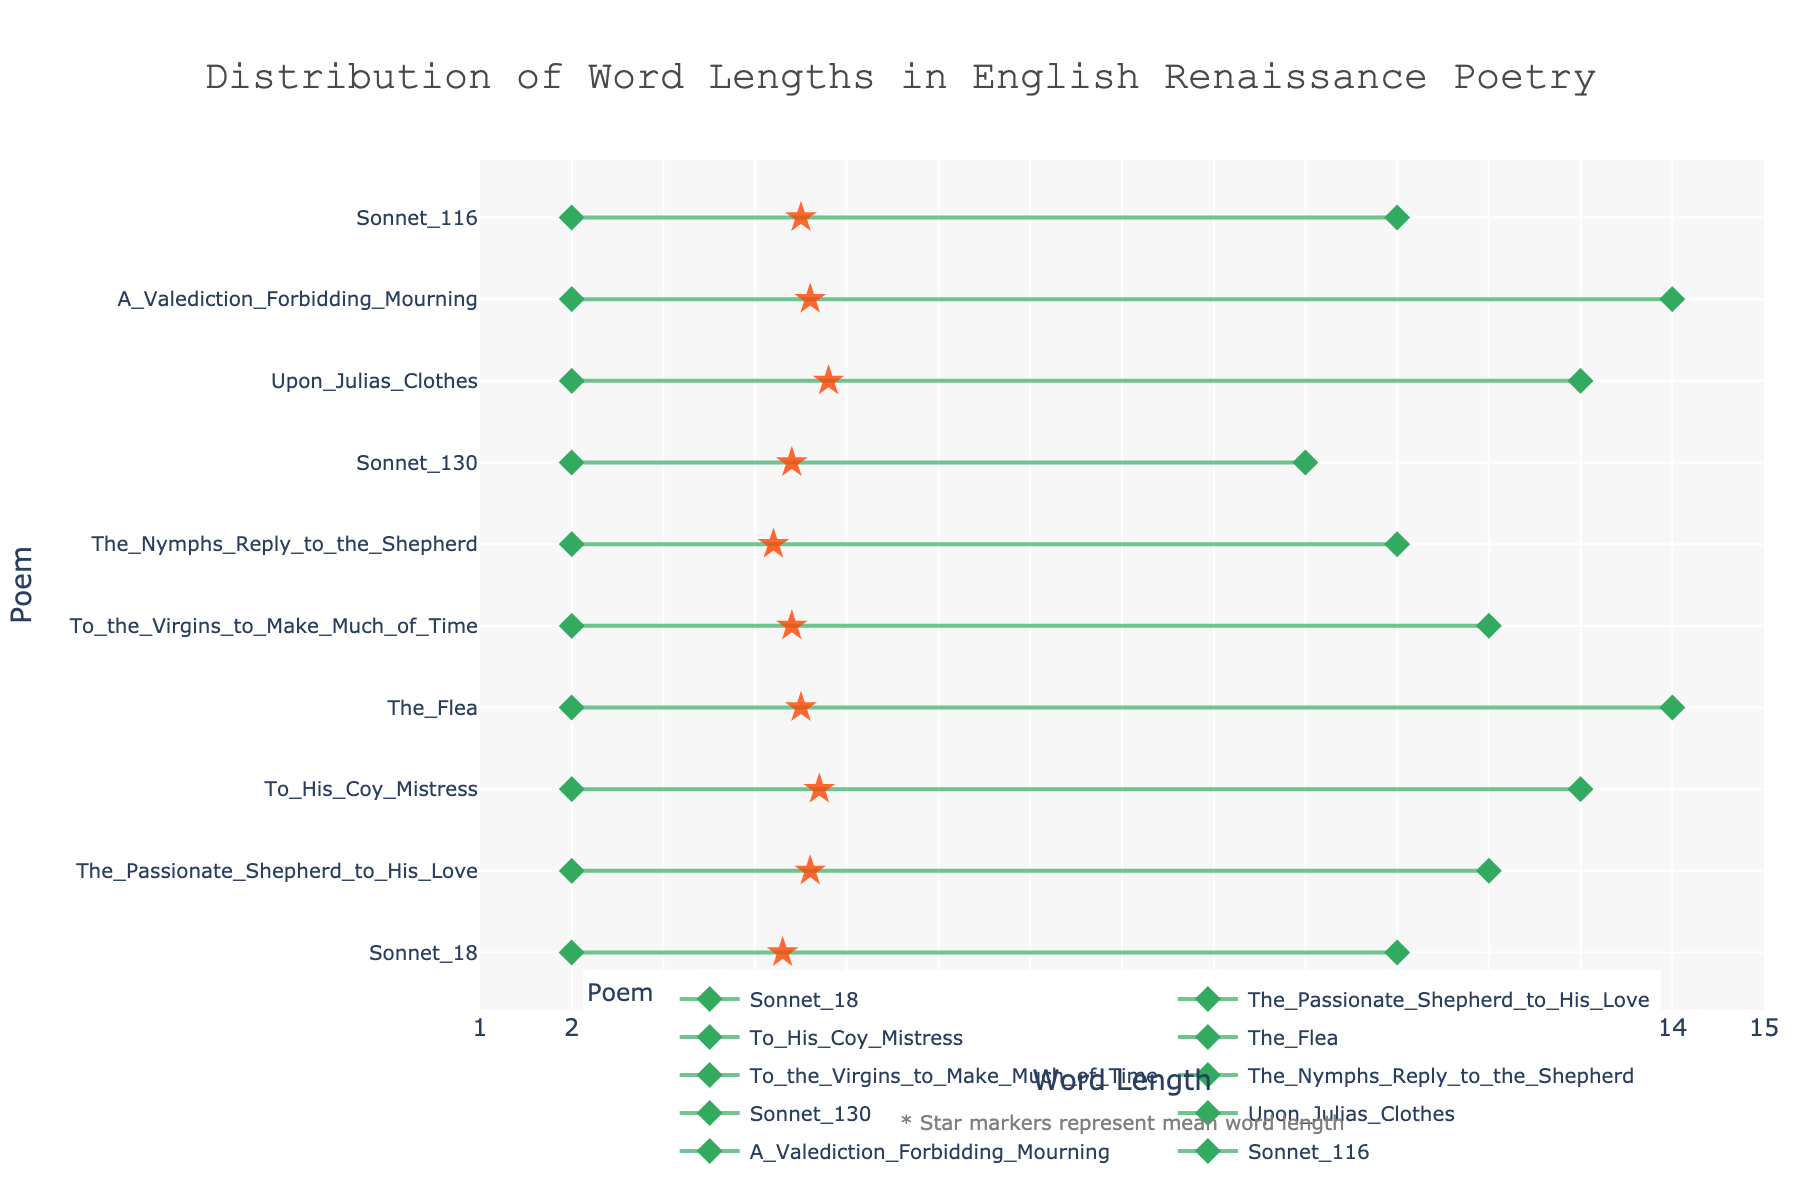What's the title of the plot? The title is usually positioned at the top of the figure. In this figure, the title is clearly written at the top.
Answer: Distribution of Word Lengths in English Renaissance Poetry What is the range of word lengths in "To His Coy Mistress"? The range is determined by looking at the minimum and maximum word lengths. According to the plot, "To His Coy Mistress" has a minimum word length of 2 and a maximum word length of 13.
Answer: 2 to 13 Which poem has the smallest word length range? To find the poem with the smallest word length range, compare the difference between the maximum and minimum word lengths across all poems. "Sonnet 130" has a range of 2 to 10, which is smaller than any other poem.
Answer: Sonnet 130 How many poems have their mean word length represented by a star within the range of 4 to 5? Count the star markers representing the mean word length that fall within the range of 4 to 5 on the x-axis. The poems are "Sonnet 18", "The Passionate Shepherd to His Love", "To His Coy Mistress", "The Flea", "To the Virgins to Make Much of Time", "The Nymphs Reply to the Shepherd", "Sonnet 130", "A Valediction Forbidding Mourning", and "Sonnet 116".
Answer: 9 What is the median word length for "Upon Julia's Clothes"? The median word length is explicitly marked for this poem. According to the plot, "Upon Julia's Clothes" has a median word length of 5.
Answer: 5 Which poem has the highest maximum word length? To find the poem with the highest maximum word length, look for the highest endpoint on the x-axis. "The Flea" and "A Valediction Forbidding Mourning" both have the highest maximum word length of 14.
Answer: The Flea and A Valediction Forbidding Mourning What is the difference between the mean word lengths of "Sonnet 18" and "To the Virgins to Make Much of Time"? To find the difference, subtract the mean word length of "Sonnet 18" (4.3) from the mean word length of "To the Virgins to Make Much of Time" (4.4).
Answer: 0.1 Which poem has a mean word length closest to 4.5? The closest mean word length to 4.5 is visible by looking at the star markers along the x-axis. "The Flea" and "Sonnet 116" both have a mean word length closest to 4.5.
Answer: The Flea and Sonnet 116 What is the visual representation used to mark the mean word length in the plot? The markers used to represent mean word length are distinct and highlighted differently from other data points. In this figure, the mean word lengths are marked with star symbols.
Answer: Star markers Which poem has a minimum word length of 2 and a maximum word length of 12? Look for the endpoints of the lines representing each poem's word length. Both "The Passionate Shepherd to His Love" and "To the Virgins to Make Much of Time" have a minimum word length of 2 and a maximum word length of 12.
Answer: The Passionate Shepherd to His Love and To the Virgins to Make Much of Time 